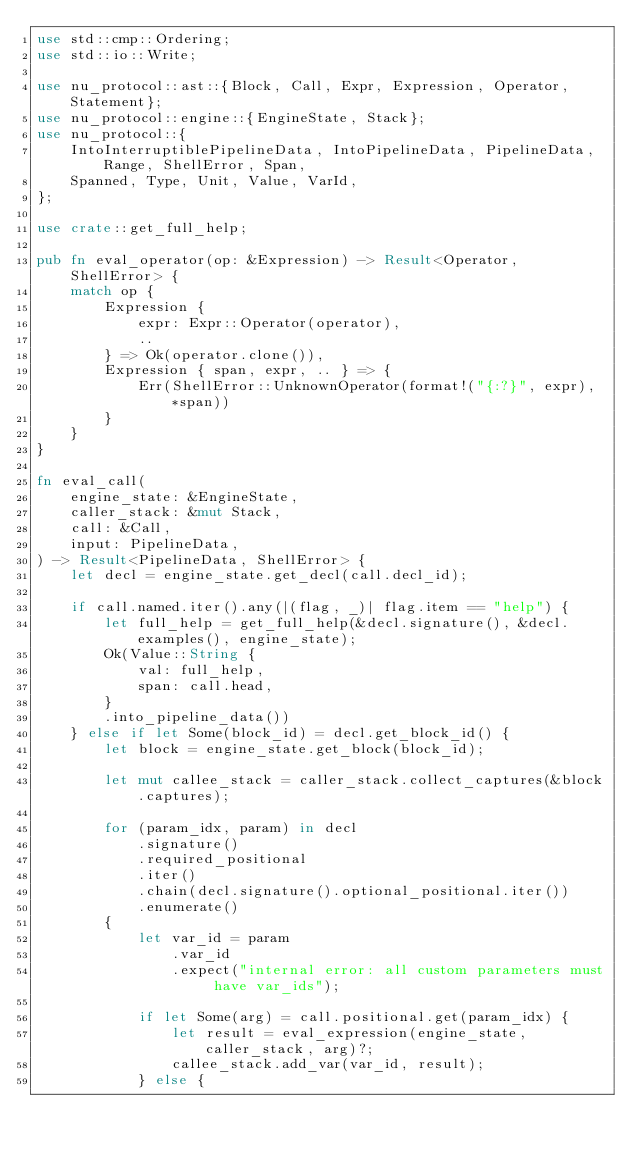Convert code to text. <code><loc_0><loc_0><loc_500><loc_500><_Rust_>use std::cmp::Ordering;
use std::io::Write;

use nu_protocol::ast::{Block, Call, Expr, Expression, Operator, Statement};
use nu_protocol::engine::{EngineState, Stack};
use nu_protocol::{
    IntoInterruptiblePipelineData, IntoPipelineData, PipelineData, Range, ShellError, Span,
    Spanned, Type, Unit, Value, VarId,
};

use crate::get_full_help;

pub fn eval_operator(op: &Expression) -> Result<Operator, ShellError> {
    match op {
        Expression {
            expr: Expr::Operator(operator),
            ..
        } => Ok(operator.clone()),
        Expression { span, expr, .. } => {
            Err(ShellError::UnknownOperator(format!("{:?}", expr), *span))
        }
    }
}

fn eval_call(
    engine_state: &EngineState,
    caller_stack: &mut Stack,
    call: &Call,
    input: PipelineData,
) -> Result<PipelineData, ShellError> {
    let decl = engine_state.get_decl(call.decl_id);

    if call.named.iter().any(|(flag, _)| flag.item == "help") {
        let full_help = get_full_help(&decl.signature(), &decl.examples(), engine_state);
        Ok(Value::String {
            val: full_help,
            span: call.head,
        }
        .into_pipeline_data())
    } else if let Some(block_id) = decl.get_block_id() {
        let block = engine_state.get_block(block_id);

        let mut callee_stack = caller_stack.collect_captures(&block.captures);

        for (param_idx, param) in decl
            .signature()
            .required_positional
            .iter()
            .chain(decl.signature().optional_positional.iter())
            .enumerate()
        {
            let var_id = param
                .var_id
                .expect("internal error: all custom parameters must have var_ids");

            if let Some(arg) = call.positional.get(param_idx) {
                let result = eval_expression(engine_state, caller_stack, arg)?;
                callee_stack.add_var(var_id, result);
            } else {</code> 